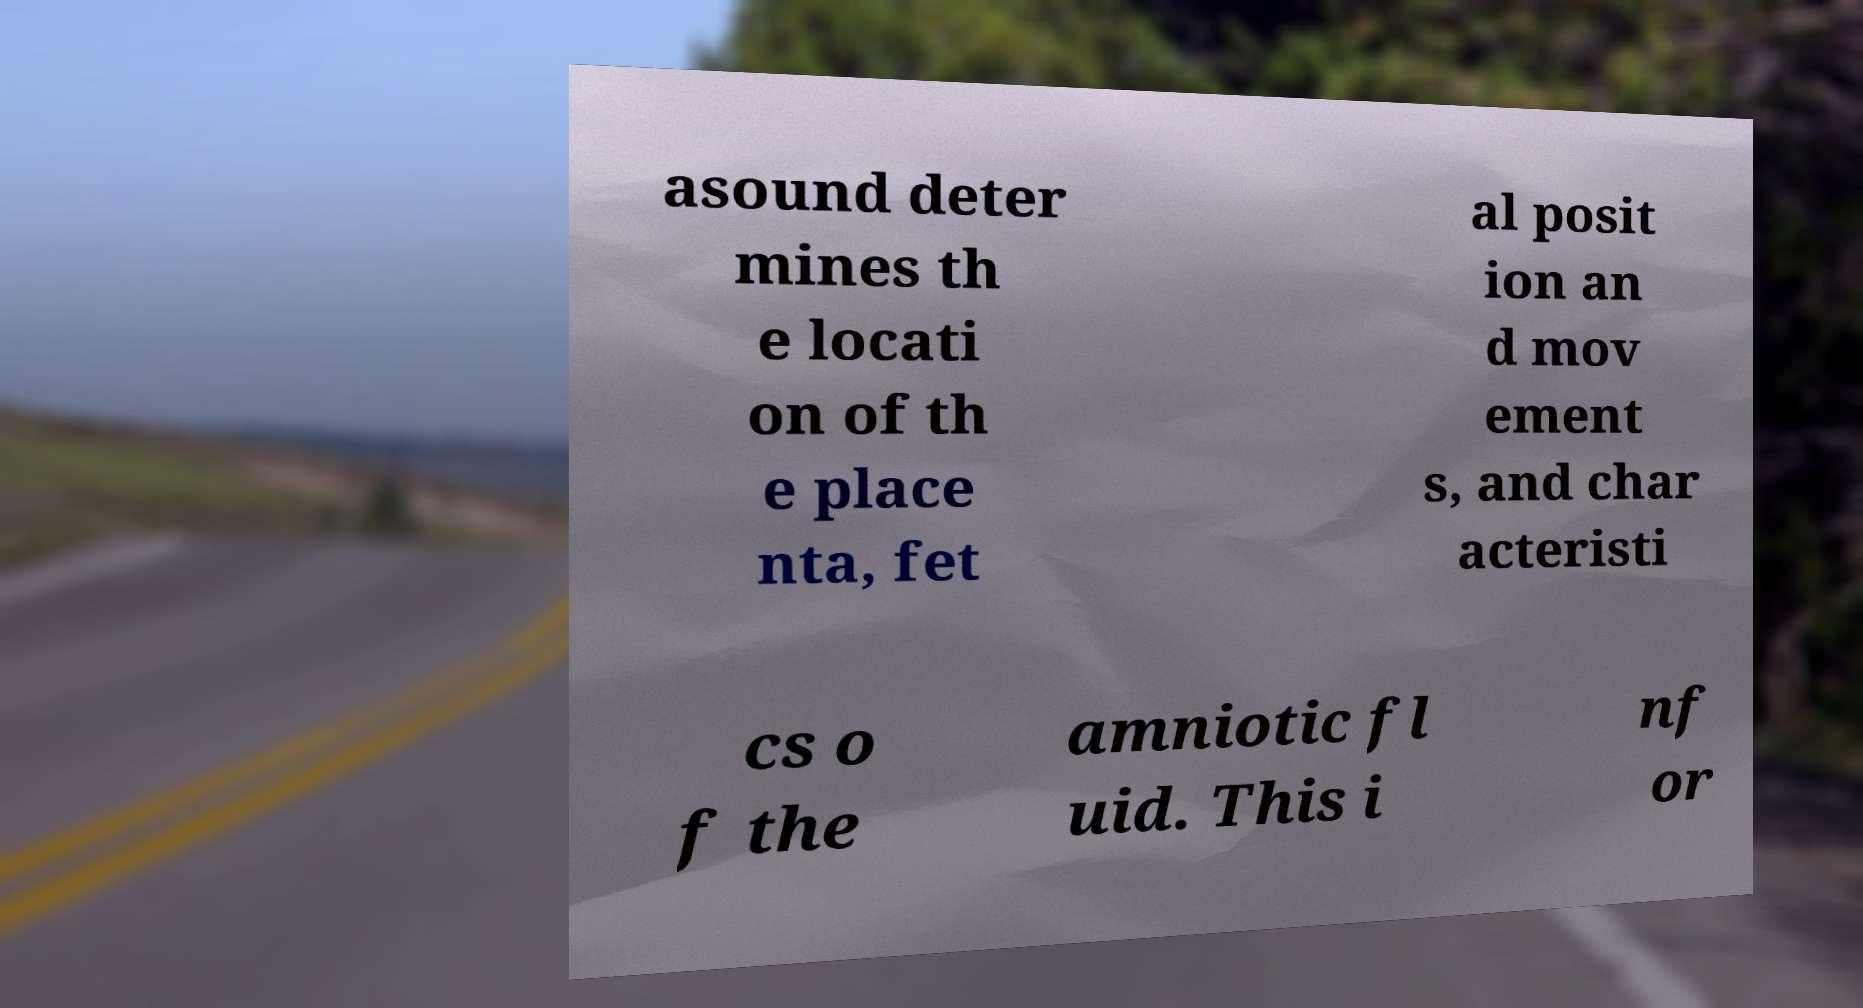What messages or text are displayed in this image? I need them in a readable, typed format. asound deter mines th e locati on of th e place nta, fet al posit ion an d mov ement s, and char acteristi cs o f the amniotic fl uid. This i nf or 